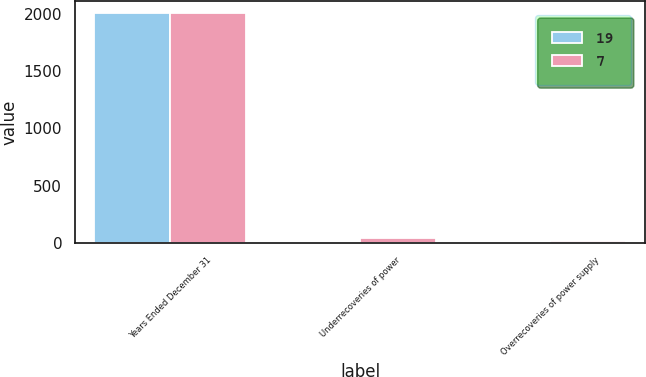<chart> <loc_0><loc_0><loc_500><loc_500><stacked_bar_chart><ecel><fcel>Years Ended December 31<fcel>Underrecoveries of power<fcel>Overrecoveries of power supply<nl><fcel>19<fcel>2008<fcel>7<fcel>7<nl><fcel>7<fcel>2007<fcel>45<fcel>19<nl></chart> 